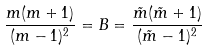<formula> <loc_0><loc_0><loc_500><loc_500>\frac { m ( m + 1 ) } { ( m - 1 ) ^ { 2 } } = B = \frac { \tilde { m } ( \tilde { m } + 1 ) } { ( \tilde { m } - 1 ) ^ { 2 } }</formula> 